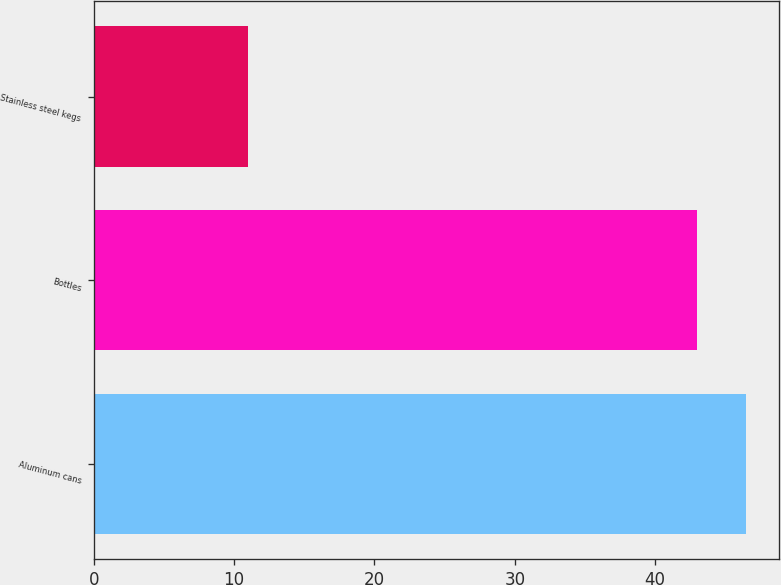Convert chart. <chart><loc_0><loc_0><loc_500><loc_500><bar_chart><fcel>Aluminum cans<fcel>Bottles<fcel>Stainless steel kegs<nl><fcel>46.5<fcel>43<fcel>11<nl></chart> 